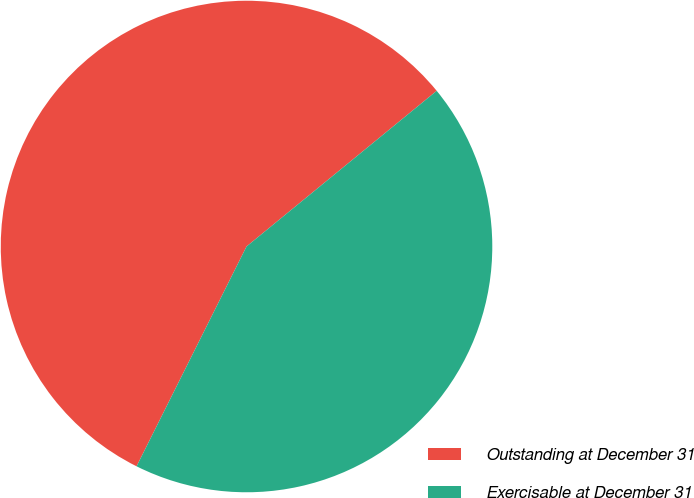Convert chart. <chart><loc_0><loc_0><loc_500><loc_500><pie_chart><fcel>Outstanding at December 31<fcel>Exercisable at December 31<nl><fcel>56.7%<fcel>43.3%<nl></chart> 